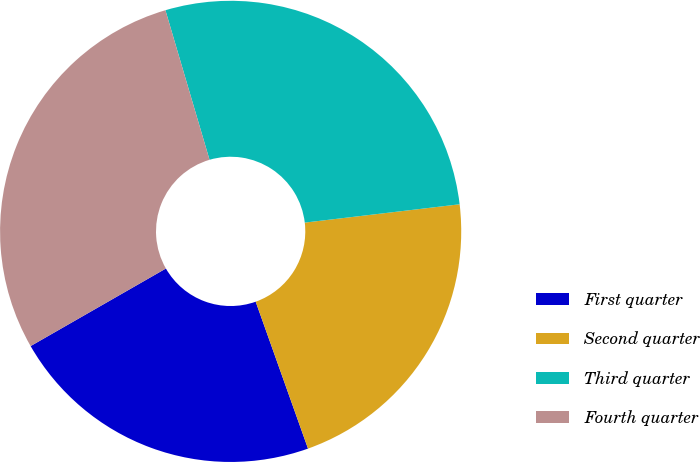Convert chart to OTSL. <chart><loc_0><loc_0><loc_500><loc_500><pie_chart><fcel>First quarter<fcel>Second quarter<fcel>Third quarter<fcel>Fourth quarter<nl><fcel>22.16%<fcel>21.43%<fcel>27.69%<fcel>28.72%<nl></chart> 